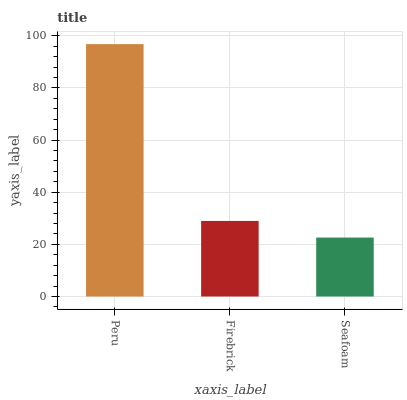Is Seafoam the minimum?
Answer yes or no. Yes. Is Peru the maximum?
Answer yes or no. Yes. Is Firebrick the minimum?
Answer yes or no. No. Is Firebrick the maximum?
Answer yes or no. No. Is Peru greater than Firebrick?
Answer yes or no. Yes. Is Firebrick less than Peru?
Answer yes or no. Yes. Is Firebrick greater than Peru?
Answer yes or no. No. Is Peru less than Firebrick?
Answer yes or no. No. Is Firebrick the high median?
Answer yes or no. Yes. Is Firebrick the low median?
Answer yes or no. Yes. Is Seafoam the high median?
Answer yes or no. No. Is Seafoam the low median?
Answer yes or no. No. 